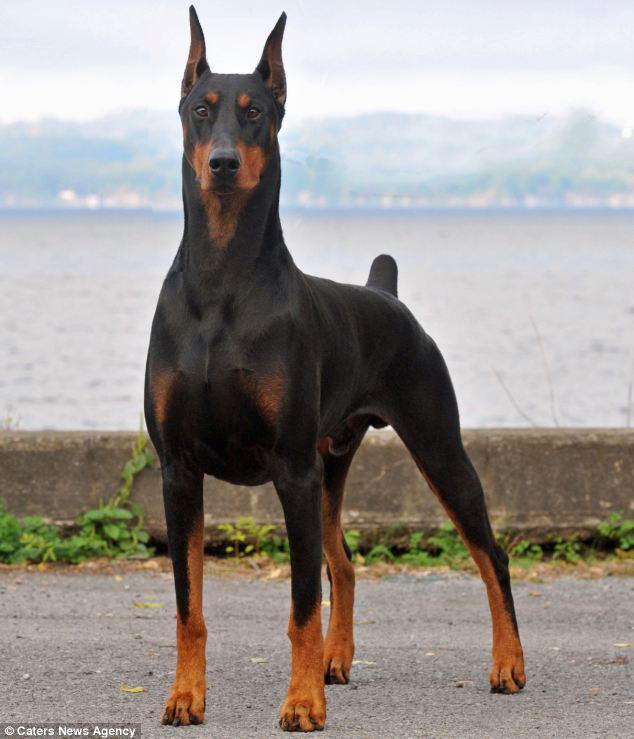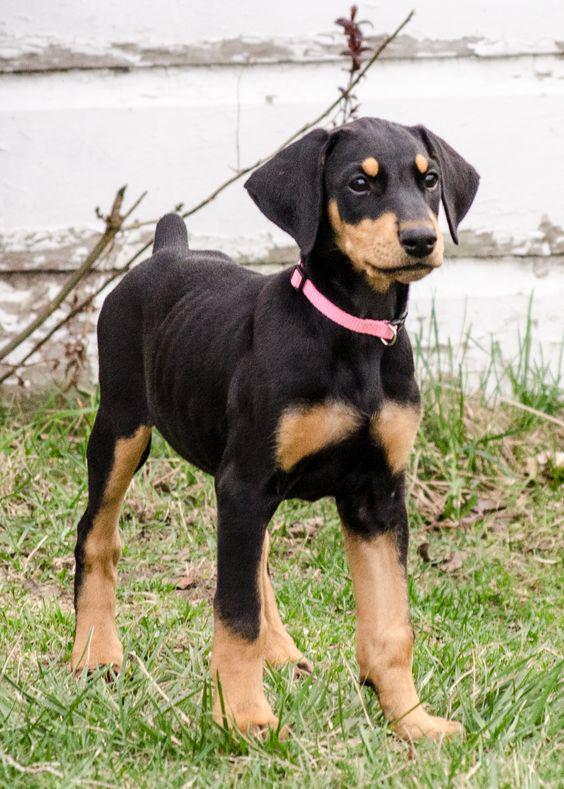The first image is the image on the left, the second image is the image on the right. Assess this claim about the two images: "The left image contains one dog facing towards the left.". Correct or not? Answer yes or no. No. The first image is the image on the left, the second image is the image on the right. Considering the images on both sides, is "Two dobermans can be seen standing at attention while outside." valid? Answer yes or no. No. 